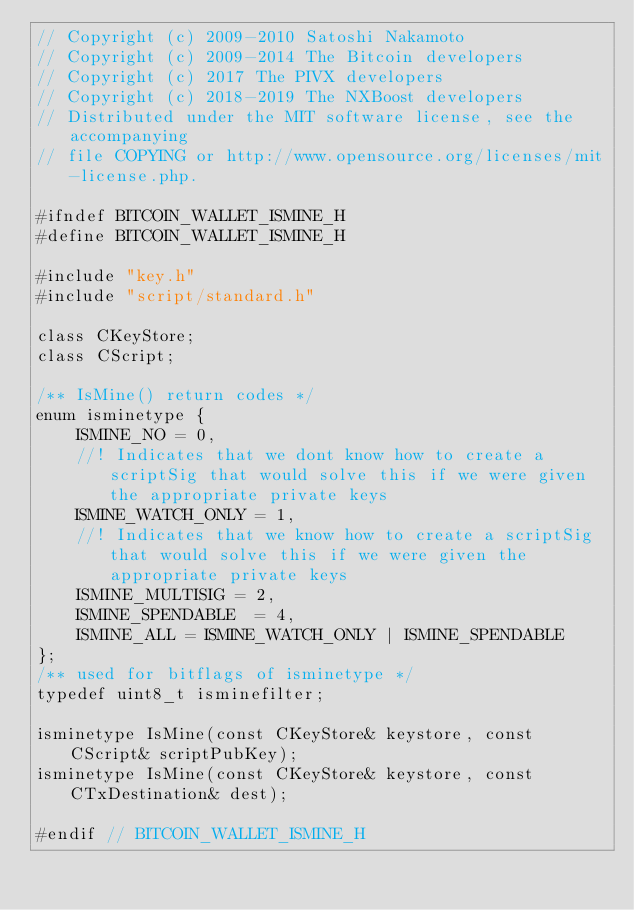Convert code to text. <code><loc_0><loc_0><loc_500><loc_500><_C_>// Copyright (c) 2009-2010 Satoshi Nakamoto
// Copyright (c) 2009-2014 The Bitcoin developers
// Copyright (c) 2017 The PIVX developers
// Copyright (c) 2018-2019 The NXBoost developers
// Distributed under the MIT software license, see the accompanying
// file COPYING or http://www.opensource.org/licenses/mit-license.php.

#ifndef BITCOIN_WALLET_ISMINE_H
#define BITCOIN_WALLET_ISMINE_H

#include "key.h"
#include "script/standard.h"

class CKeyStore;
class CScript;

/** IsMine() return codes */
enum isminetype {
    ISMINE_NO = 0,
    //! Indicates that we dont know how to create a scriptSig that would solve this if we were given the appropriate private keys
    ISMINE_WATCH_ONLY = 1,
    //! Indicates that we know how to create a scriptSig that would solve this if we were given the appropriate private keys
    ISMINE_MULTISIG = 2,
    ISMINE_SPENDABLE  = 4,
    ISMINE_ALL = ISMINE_WATCH_ONLY | ISMINE_SPENDABLE
};
/** used for bitflags of isminetype */
typedef uint8_t isminefilter;

isminetype IsMine(const CKeyStore& keystore, const CScript& scriptPubKey);
isminetype IsMine(const CKeyStore& keystore, const CTxDestination& dest);

#endif // BITCOIN_WALLET_ISMINE_H
</code> 